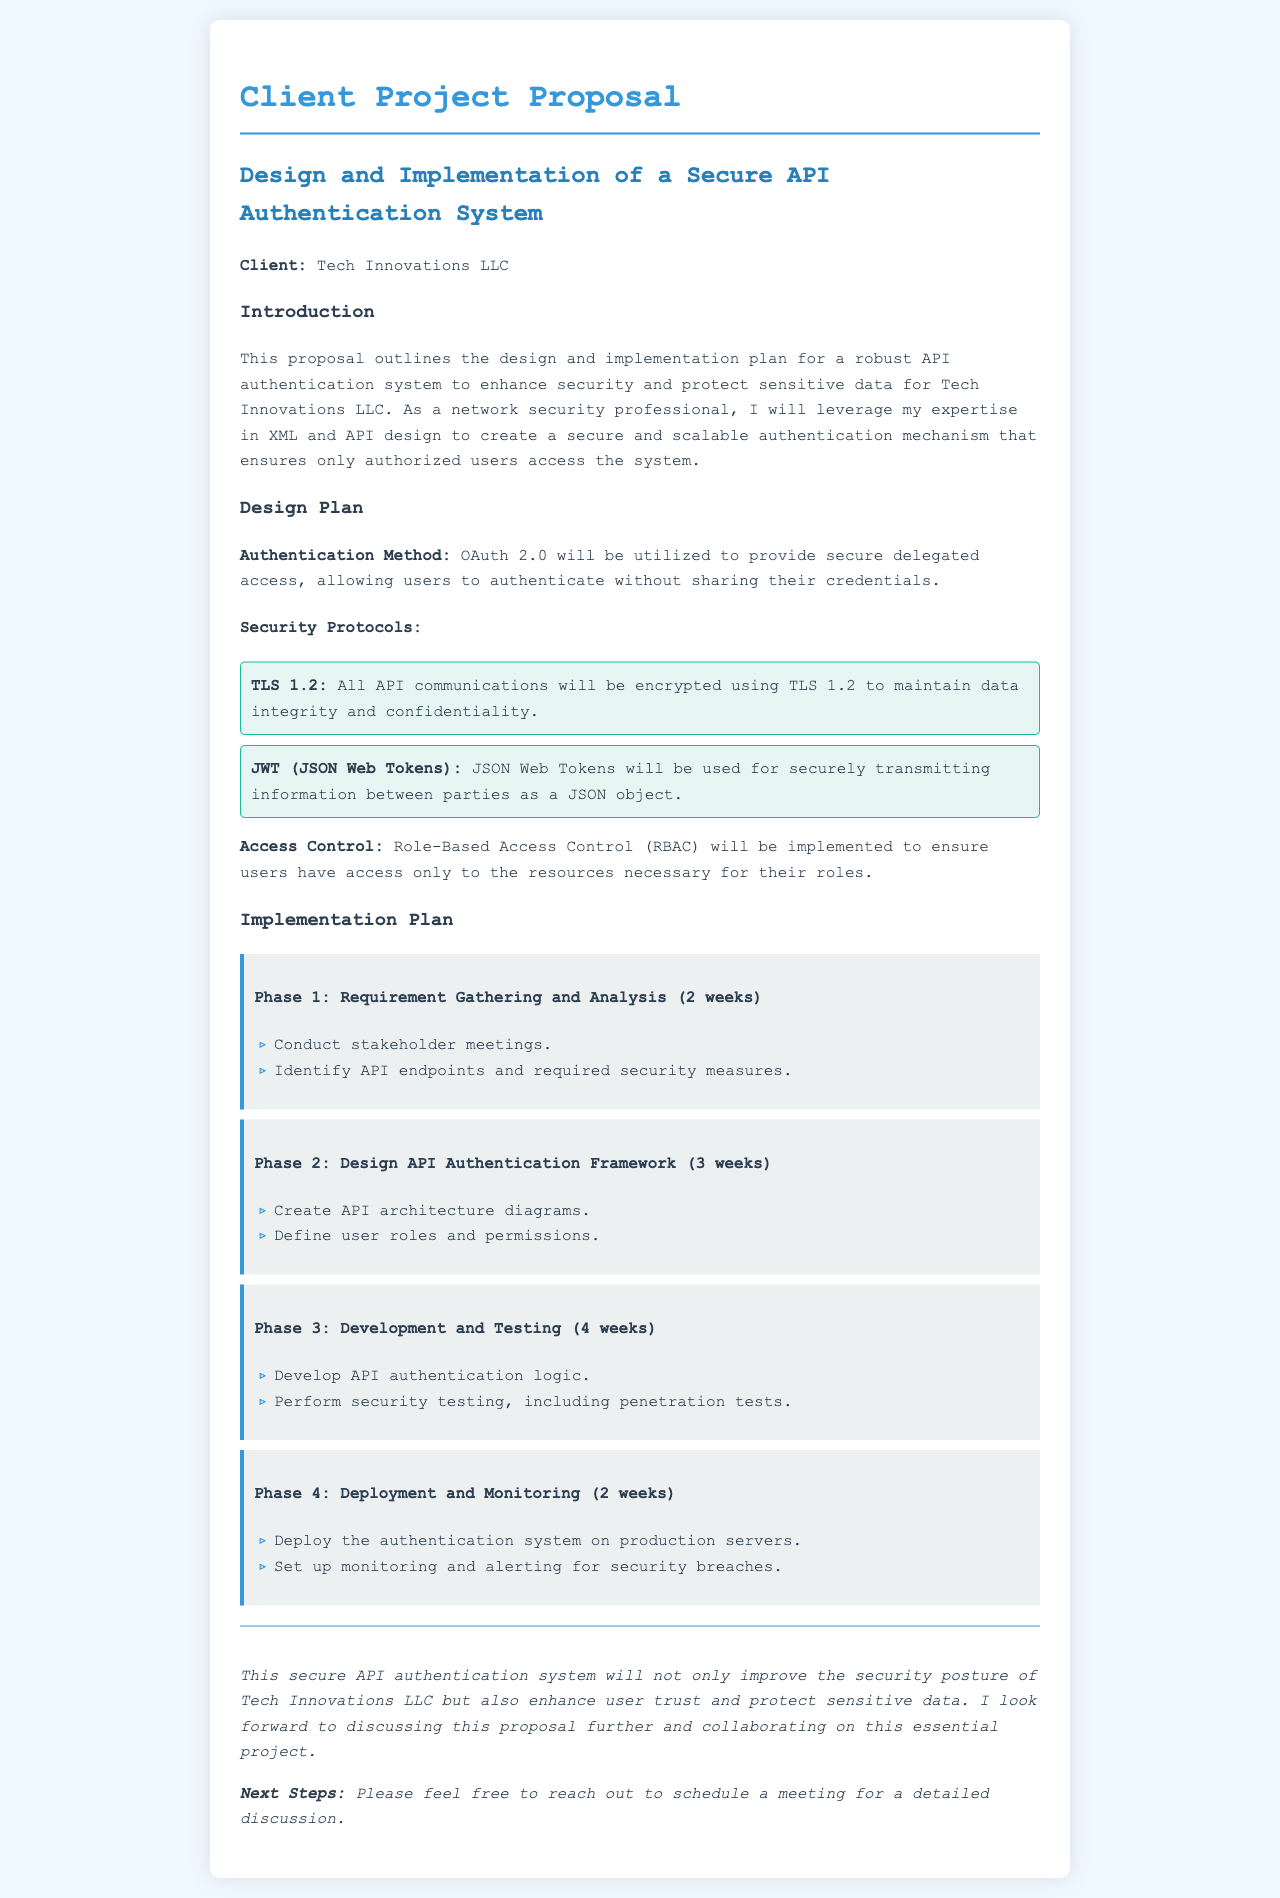What is the client name? The client name is specified in the document under the client section, which states "Tech Innovations LLC."
Answer: Tech Innovations LLC What authentication method will be utilized? The authentication method mentioned in the design plan is OAuth 2.0, providing secure delegated access.
Answer: OAuth 2.0 How many weeks is Phase 1 scheduled to take? The duration of Phase 1, as stated in the implementation plan, is 2 weeks.
Answer: 2 weeks What is one of the security protocols used for API communications? The document specifies that TLS 1.2 will be used for encryption of API communications.
Answer: TLS 1.2 What type of access control will be implemented? The access control method mentioned in the proposal is Role-Based Access Control (RBAC).
Answer: Role-Based Access Control What is the total duration of the implementation plan? By adding all the phases together: 2 + 3 + 4 + 2 = 11 weeks total for implementation.
Answer: 11 weeks What will be set up during Phase 4? The monitoring and alerting systems for security breaches will be set up during Phase 4.
Answer: Monitoring and alerting What is the main goal of the proposed system? The conclusion highlights that the main goal is to improve the security posture and protect sensitive data.
Answer: Improve security posture 